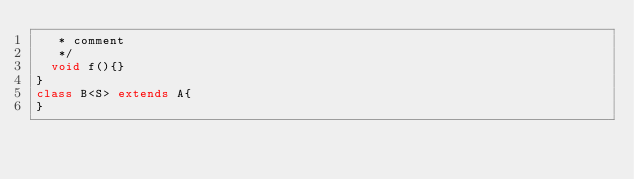Convert code to text. <code><loc_0><loc_0><loc_500><loc_500><_Java_>	 * comment
	 */
	void f(){}
}
class B<S> extends A{
}</code> 